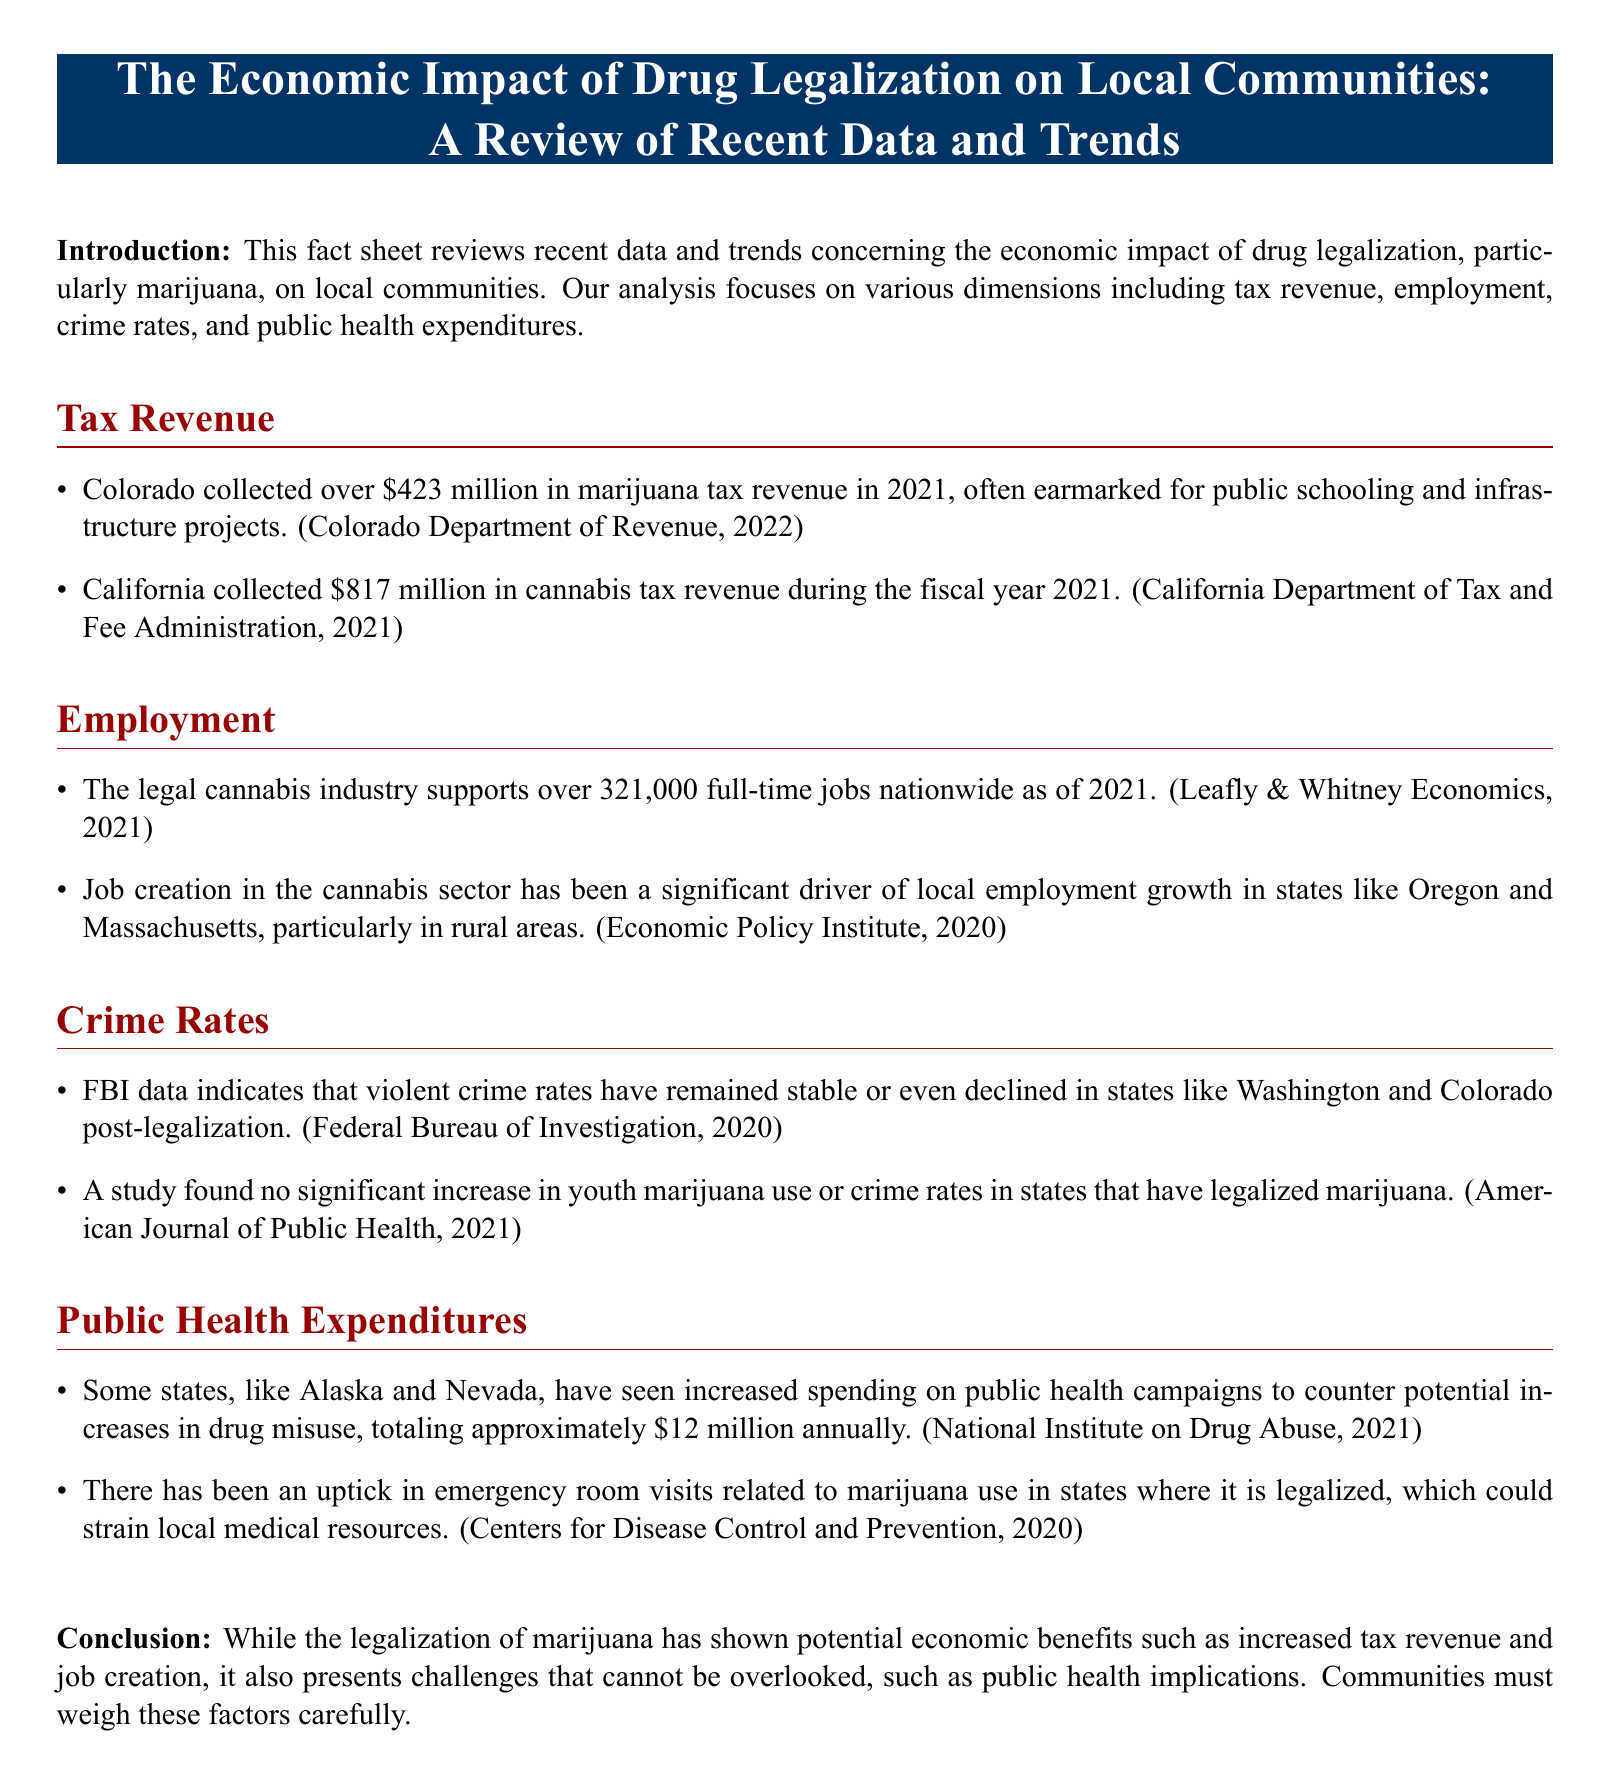what was Colorado's marijuana tax revenue in 2021? The document states that Colorado collected over $423 million in marijuana tax revenue in 2021.
Answer: $423 million what is the total cannabis tax revenue collected by California in the fiscal year 2021? According to the document, California collected $817 million in cannabis tax revenue during the fiscal year 2021.
Answer: $817 million how many full-time jobs does the legal cannabis industry support nationwide as of 2021? The fact sheet mentions that the legal cannabis industry supports over 321,000 full-time jobs nationwide as of 2021.
Answer: 321,000 what impact did marijuana legalization have on violent crime rates in states like Washington and Colorado? The document indicates that FBI data shows violent crime rates have remained stable or even declined in these states post-legalization.
Answer: Stable or declined how much is allocated annually for public health campaigns in states like Alaska and Nevada? The document states that states like Alaska and Nevada have increased spending on public health campaigns to about $12 million annually.
Answer: $12 million what has caused an uptick in emergency room visits in legalized states? The fact sheet mentions that there has been an uptick in emergency room visits related to marijuana use in states where it is legalized.
Answer: Marijuana use what are two benefits of marijuana legalization mentioned in the conclusion? The conclusion highlights two benefits: increased tax revenue and job creation.
Answer: Increased tax revenue and job creation what challenges do communities face as a result of marijuana legalization? The document notes that public health implications are a challenge that communities must consider.
Answer: Public health implications what does the term "legal cannabis industry" refer to in the context of this document? The term refers to the sector involving the cultivation, distribution, and sale of marijuana that has been legalized.
Answer: Cultivation, distribution, and sale of marijuana 